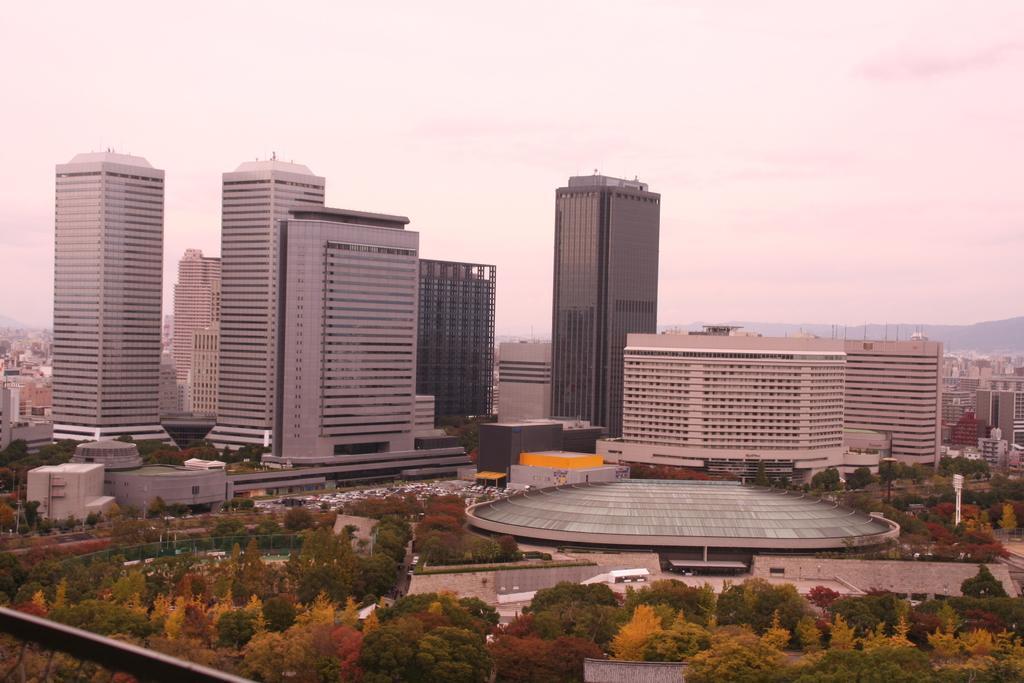Could you give a brief overview of what you see in this image? In this picture we can see few trees, buildings and hills. 